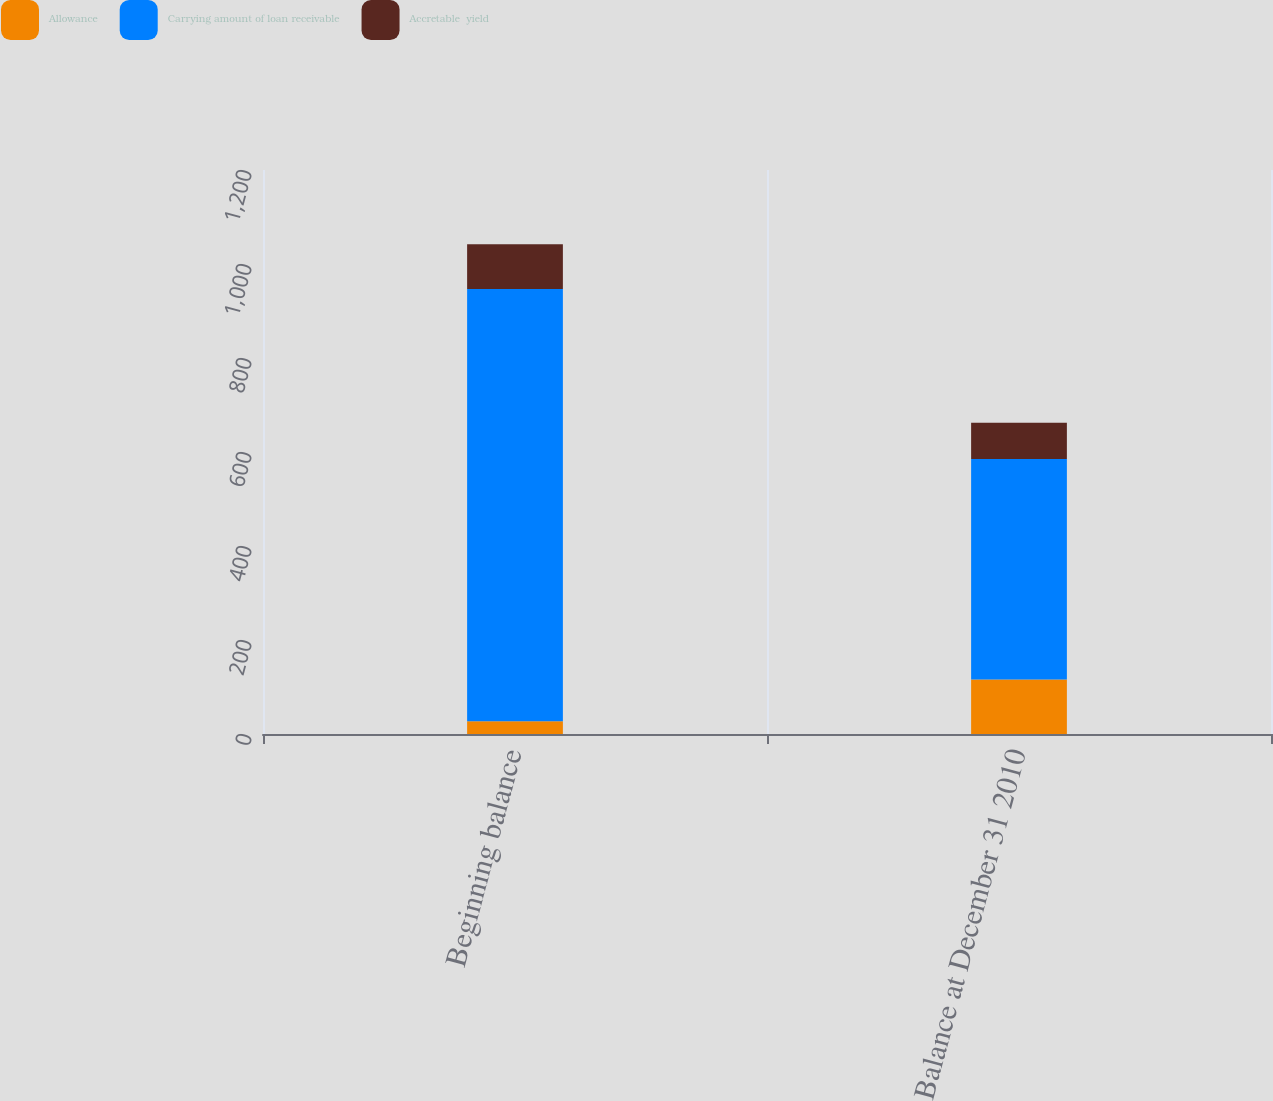<chart> <loc_0><loc_0><loc_500><loc_500><stacked_bar_chart><ecel><fcel>Beginning balance<fcel>Balance at December 31 2010<nl><fcel>Allowance<fcel>27<fcel>116<nl><fcel>Carrying amount of loan receivable<fcel>920<fcel>469<nl><fcel>Accretable  yield<fcel>95<fcel>77<nl></chart> 